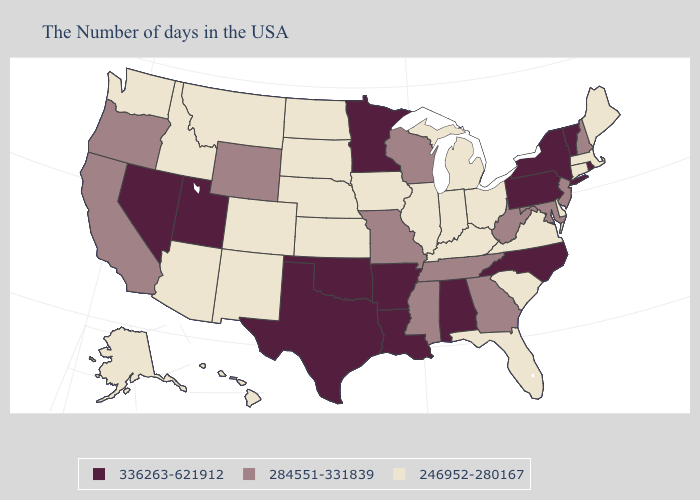Does the first symbol in the legend represent the smallest category?
Be succinct. No. Among the states that border Kentucky , which have the highest value?
Concise answer only. West Virginia, Tennessee, Missouri. What is the lowest value in states that border Kansas?
Quick response, please. 246952-280167. Among the states that border Delaware , does Pennsylvania have the lowest value?
Be succinct. No. What is the highest value in the Northeast ?
Write a very short answer. 336263-621912. Does Washington have a lower value than Arizona?
Keep it brief. No. What is the value of Illinois?
Quick response, please. 246952-280167. What is the value of Kansas?
Write a very short answer. 246952-280167. Name the states that have a value in the range 246952-280167?
Short answer required. Maine, Massachusetts, Connecticut, Delaware, Virginia, South Carolina, Ohio, Florida, Michigan, Kentucky, Indiana, Illinois, Iowa, Kansas, Nebraska, South Dakota, North Dakota, Colorado, New Mexico, Montana, Arizona, Idaho, Washington, Alaska, Hawaii. What is the highest value in the USA?
Give a very brief answer. 336263-621912. What is the value of Pennsylvania?
Write a very short answer. 336263-621912. Does New York have the highest value in the USA?
Answer briefly. Yes. Does South Carolina have the highest value in the South?
Quick response, please. No. Is the legend a continuous bar?
Be succinct. No. Among the states that border Louisiana , does Mississippi have the highest value?
Be succinct. No. 